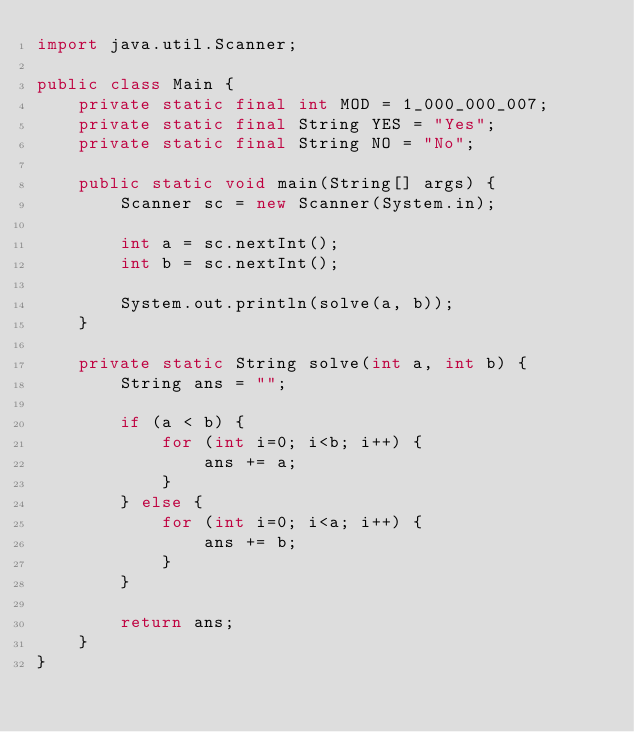<code> <loc_0><loc_0><loc_500><loc_500><_Java_>import java.util.Scanner;

public class Main {
    private static final int MOD = 1_000_000_007;
    private static final String YES = "Yes";
    private static final String NO = "No";

    public static void main(String[] args) {
        Scanner sc = new Scanner(System.in);

        int a = sc.nextInt();
        int b = sc.nextInt();

        System.out.println(solve(a, b));
    }

    private static String solve(int a, int b) {
        String ans = "";

        if (a < b) {
            for (int i=0; i<b; i++) {
                ans += a;
            }
        } else {
            for (int i=0; i<a; i++) {
                ans += b;
            }
        }

        return ans;
    }
}</code> 